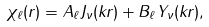<formula> <loc_0><loc_0><loc_500><loc_500>\chi _ { \ell } ( r ) = A _ { \ell } J _ { \nu } ( k r ) + B _ { \ell } Y _ { \nu } ( k r ) ,</formula> 